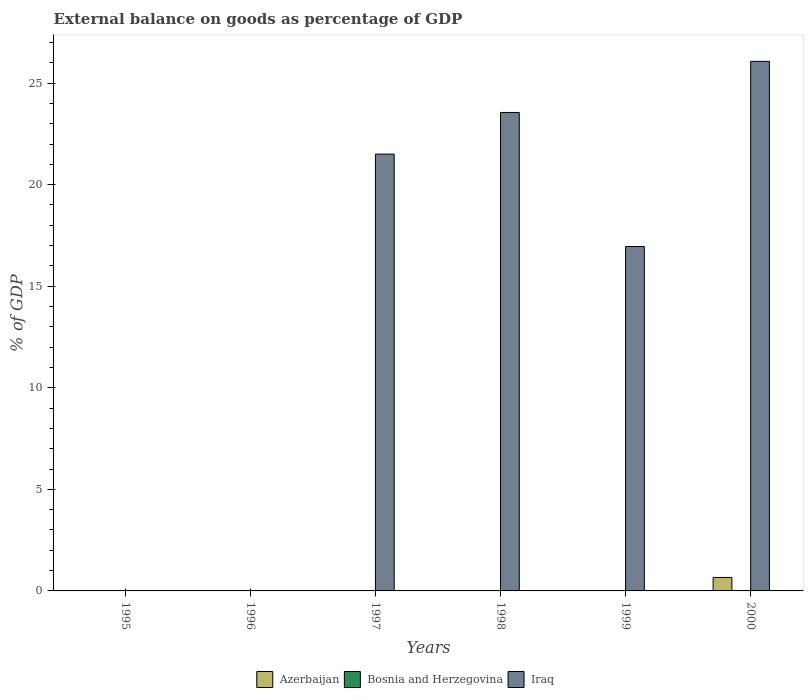Are the number of bars on each tick of the X-axis equal?
Offer a very short reply. No. How many bars are there on the 4th tick from the right?
Keep it short and to the point. 1. What is the label of the 1st group of bars from the left?
Your answer should be compact. 1995. In how many cases, is the number of bars for a given year not equal to the number of legend labels?
Your answer should be very brief. 6. What is the external balance on goods as percentage of GDP in Bosnia and Herzegovina in 2000?
Your response must be concise. 0. Across all years, what is the maximum external balance on goods as percentage of GDP in Azerbaijan?
Provide a succinct answer. 0.66. What is the total external balance on goods as percentage of GDP in Bosnia and Herzegovina in the graph?
Make the answer very short. 0. What is the average external balance on goods as percentage of GDP in Iraq per year?
Your answer should be very brief. 14.68. What is the difference between the highest and the second highest external balance on goods as percentage of GDP in Iraq?
Keep it short and to the point. 2.52. What is the difference between the highest and the lowest external balance on goods as percentage of GDP in Azerbaijan?
Provide a short and direct response. 0.66. In how many years, is the external balance on goods as percentage of GDP in Iraq greater than the average external balance on goods as percentage of GDP in Iraq taken over all years?
Provide a succinct answer. 4. Is it the case that in every year, the sum of the external balance on goods as percentage of GDP in Bosnia and Herzegovina and external balance on goods as percentage of GDP in Azerbaijan is greater than the external balance on goods as percentage of GDP in Iraq?
Your answer should be compact. No. How many years are there in the graph?
Ensure brevity in your answer.  6. Where does the legend appear in the graph?
Make the answer very short. Bottom center. What is the title of the graph?
Your answer should be compact. External balance on goods as percentage of GDP. Does "Malaysia" appear as one of the legend labels in the graph?
Provide a short and direct response. No. What is the label or title of the Y-axis?
Offer a terse response. % of GDP. What is the % of GDP of Azerbaijan in 1995?
Offer a very short reply. 0. What is the % of GDP of Iraq in 1995?
Provide a short and direct response. 0. What is the % of GDP of Iraq in 1996?
Provide a short and direct response. 0. What is the % of GDP in Azerbaijan in 1997?
Offer a terse response. 0. What is the % of GDP in Bosnia and Herzegovina in 1997?
Your answer should be very brief. 0. What is the % of GDP of Iraq in 1997?
Provide a succinct answer. 21.51. What is the % of GDP of Iraq in 1998?
Make the answer very short. 23.55. What is the % of GDP in Bosnia and Herzegovina in 1999?
Offer a terse response. 0. What is the % of GDP in Iraq in 1999?
Offer a terse response. 16.96. What is the % of GDP in Azerbaijan in 2000?
Provide a succinct answer. 0.66. What is the % of GDP of Iraq in 2000?
Your answer should be compact. 26.07. Across all years, what is the maximum % of GDP in Azerbaijan?
Give a very brief answer. 0.66. Across all years, what is the maximum % of GDP in Iraq?
Your answer should be very brief. 26.07. Across all years, what is the minimum % of GDP of Azerbaijan?
Ensure brevity in your answer.  0. Across all years, what is the minimum % of GDP of Iraq?
Ensure brevity in your answer.  0. What is the total % of GDP of Azerbaijan in the graph?
Ensure brevity in your answer.  0.66. What is the total % of GDP in Iraq in the graph?
Your response must be concise. 88.09. What is the difference between the % of GDP of Iraq in 1997 and that in 1998?
Your response must be concise. -2.05. What is the difference between the % of GDP in Iraq in 1997 and that in 1999?
Offer a very short reply. 4.55. What is the difference between the % of GDP of Iraq in 1997 and that in 2000?
Offer a terse response. -4.57. What is the difference between the % of GDP of Iraq in 1998 and that in 1999?
Your answer should be very brief. 6.6. What is the difference between the % of GDP in Iraq in 1998 and that in 2000?
Offer a very short reply. -2.52. What is the difference between the % of GDP of Iraq in 1999 and that in 2000?
Provide a succinct answer. -9.12. What is the average % of GDP in Azerbaijan per year?
Ensure brevity in your answer.  0.11. What is the average % of GDP of Bosnia and Herzegovina per year?
Your answer should be compact. 0. What is the average % of GDP in Iraq per year?
Your answer should be compact. 14.68. In the year 2000, what is the difference between the % of GDP of Azerbaijan and % of GDP of Iraq?
Your answer should be compact. -25.41. What is the ratio of the % of GDP of Iraq in 1997 to that in 1998?
Your answer should be compact. 0.91. What is the ratio of the % of GDP of Iraq in 1997 to that in 1999?
Ensure brevity in your answer.  1.27. What is the ratio of the % of GDP of Iraq in 1997 to that in 2000?
Offer a terse response. 0.82. What is the ratio of the % of GDP of Iraq in 1998 to that in 1999?
Your answer should be very brief. 1.39. What is the ratio of the % of GDP in Iraq in 1998 to that in 2000?
Your response must be concise. 0.9. What is the ratio of the % of GDP of Iraq in 1999 to that in 2000?
Ensure brevity in your answer.  0.65. What is the difference between the highest and the second highest % of GDP in Iraq?
Offer a terse response. 2.52. What is the difference between the highest and the lowest % of GDP in Azerbaijan?
Provide a succinct answer. 0.66. What is the difference between the highest and the lowest % of GDP of Iraq?
Keep it short and to the point. 26.07. 